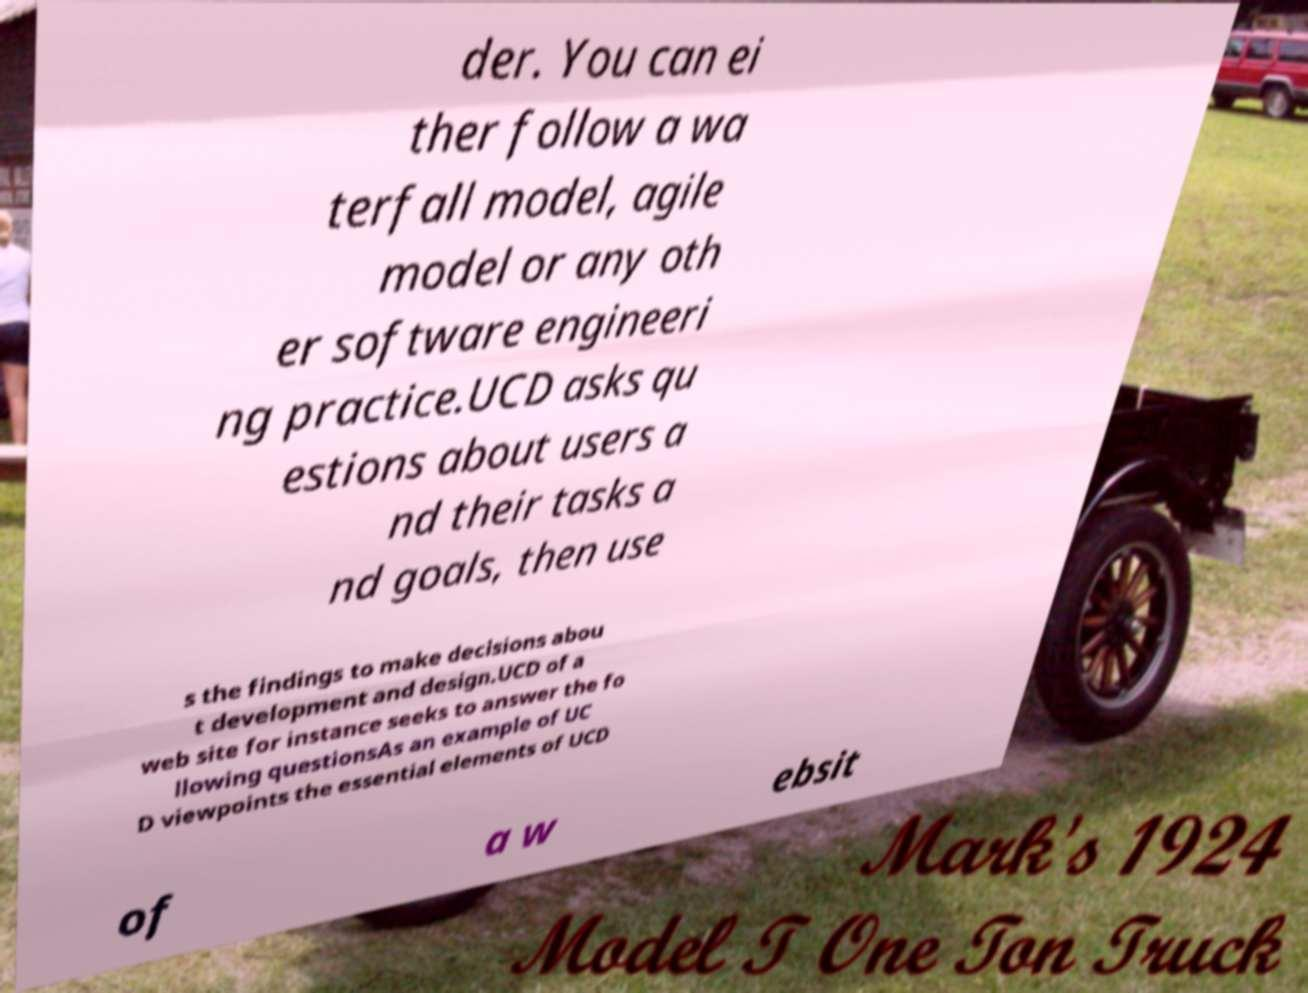What messages or text are displayed in this image? I need them in a readable, typed format. der. You can ei ther follow a wa terfall model, agile model or any oth er software engineeri ng practice.UCD asks qu estions about users a nd their tasks a nd goals, then use s the findings to make decisions abou t development and design.UCD of a web site for instance seeks to answer the fo llowing questionsAs an example of UC D viewpoints the essential elements of UCD of a w ebsit 